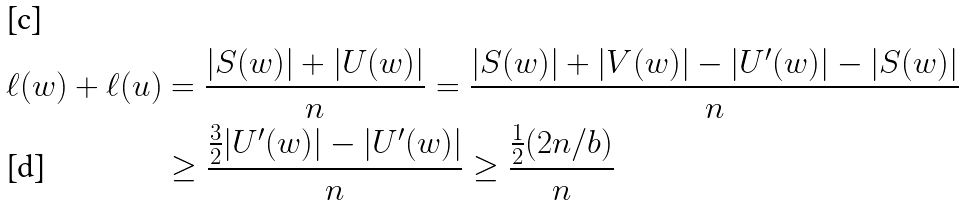Convert formula to latex. <formula><loc_0><loc_0><loc_500><loc_500>\ell ( w ) + \ell ( u ) & = \frac { | S ( w ) | + | U ( w ) | } { n } = \frac { | S ( w ) | + | V ( w ) | - | U ^ { \prime } ( w ) | - | S ( w ) | } { n } \\ & \geq \frac { \frac { 3 } { 2 } | U ^ { \prime } ( w ) | - | U ^ { \prime } ( w ) | } { n } \geq \frac { \frac { 1 } { 2 } ( 2 n / b ) } { n }</formula> 